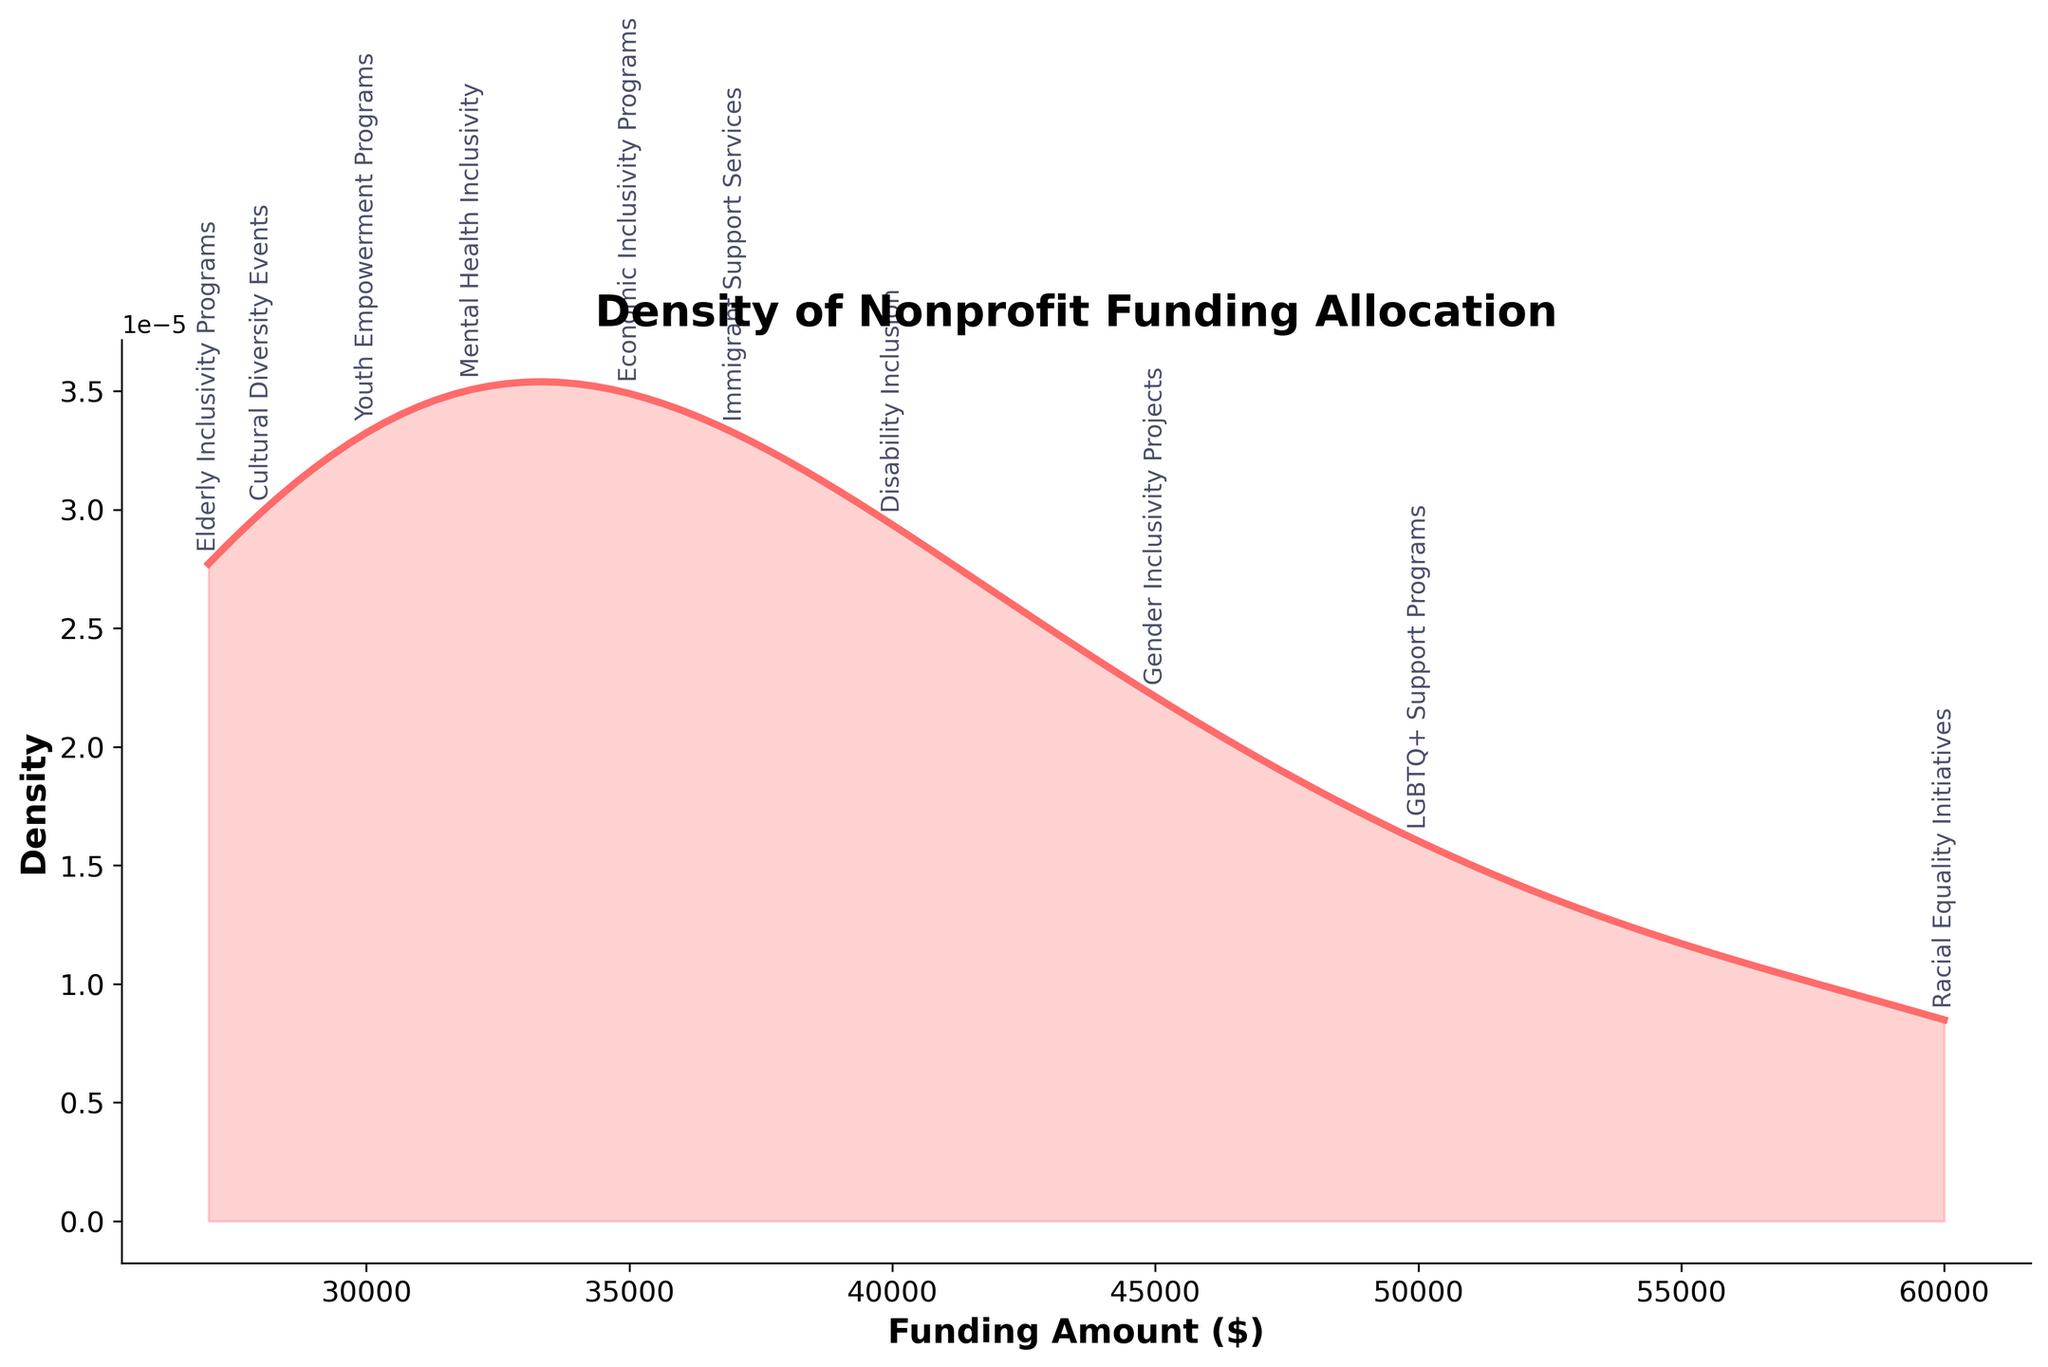What is the title of the plot? The title of the plot is displayed at the top and reads "Density of Nonprofit Funding Allocation".
Answer: Density of Nonprofit Funding Allocation What is the highest funding amount allocated to any category? By examining the annotations and the location of peaks, the highest funding amount allocated to any category can be identified as $60,000 for Racial Equality Initiatives.
Answer: $60,000 What does the y-axis represent in the plot? The y-axis represents the density, as labeled in the plot.
Answer: Density What is the funding amount for Gender Inclusivity Projects? By looking at the x-axis and locating the annotation for Gender Inclusivity Projects, the funding amount is identified as $45,000.
Answer: $45,000 Which category received the lowest funding allocation? The lowest funding allocation is identified by finding the minimum x-axis value and the corresponding annotation, which is Elderly Inclusivity Programs at $27,000.
Answer: Elderly Inclusivity Programs Is the funding allocation for Mental Health Inclusivity higher or lower than that for Youth Empowerment Programs? Comparing the annotated funding amounts for Mental Health Inclusivity ($32,000) and Youth Empowerment Programs ($30,000), Mental Health Inclusivity is higher.
Answer: Higher How does the funding amount for Cultural Diversity Events compare to that for Immigrant Support Services? By comparing the annotated funding amounts, Cultural Diversity Events is $28,000 and Immigrant Support Services is $37,000. Cultural Diversity Events receive less funding.
Answer: Less What is the range of funding amounts allocated to the categories? The range is calculated by subtracting the smallest funding amount ($27,000) from the highest funding amount ($60,000).
Answer: $33,000 Which category appears to be closest to the average funding amount when visually inspecting the density plot? By visually inspecting the density plot and considering the position of the peak near the average, we see that Disability Inclusion ($40,000) appears closest to the average funding amount.
Answer: Disability Inclusion At approximately what amount does the density plot show the highest peak? Examining the highest peak of the density plot along the x-axis, it occurs around the funding amount of $45,000.
Answer: $45,000 